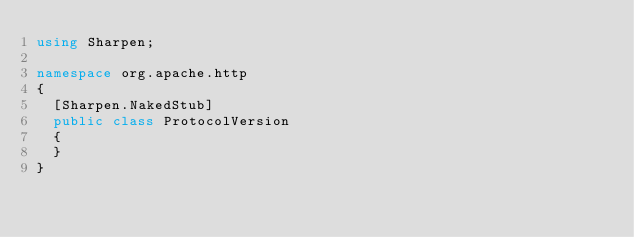Convert code to text. <code><loc_0><loc_0><loc_500><loc_500><_C#_>using Sharpen;

namespace org.apache.http
{
	[Sharpen.NakedStub]
	public class ProtocolVersion
	{
	}
}
</code> 